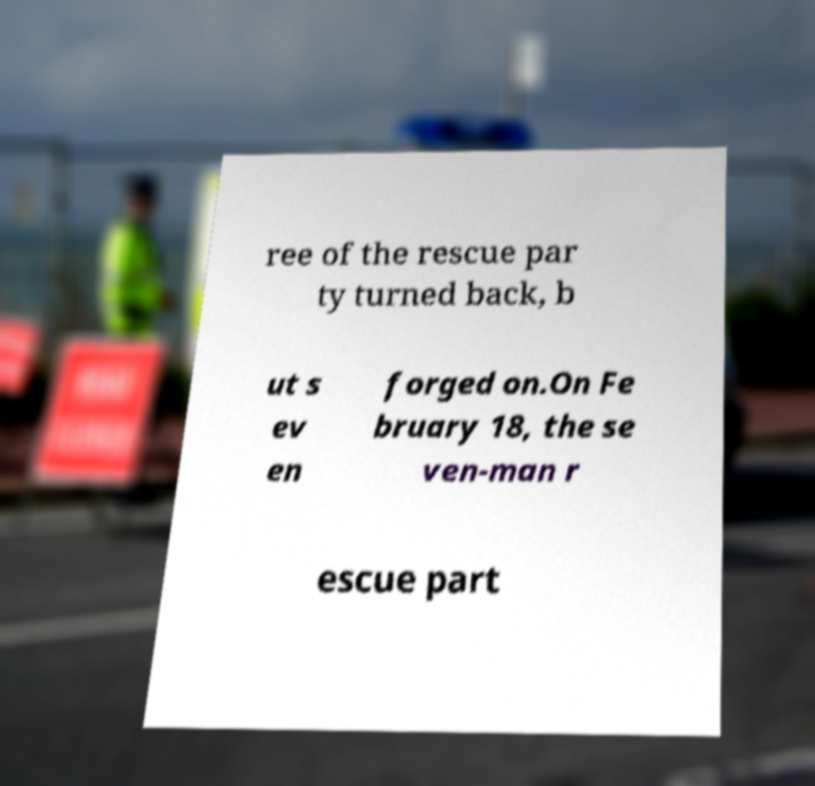Please identify and transcribe the text found in this image. ree of the rescue par ty turned back, b ut s ev en forged on.On Fe bruary 18, the se ven-man r escue part 